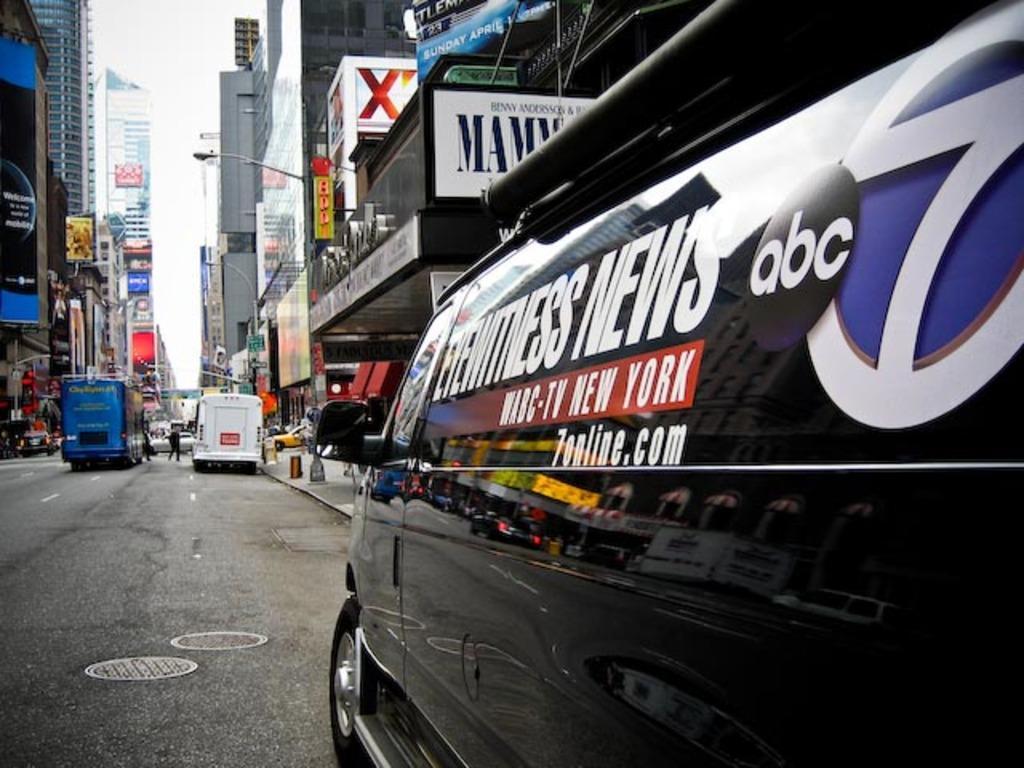Can you describe this image briefly? In the center of the image we can see buildings, boards, electric lights, some vehicles, person's, wall. At the bottom of the image we can see the road. At the top of the image we can see the sky. 